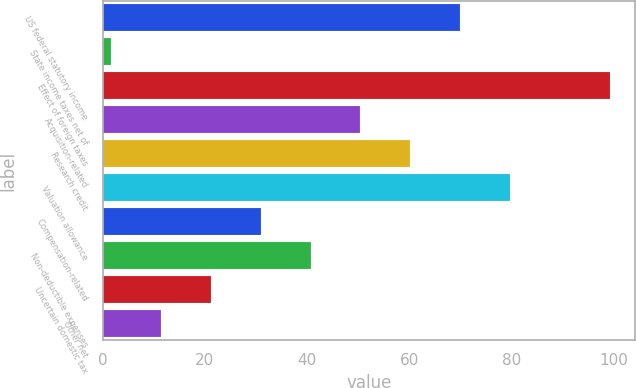Convert chart to OTSL. <chart><loc_0><loc_0><loc_500><loc_500><bar_chart><fcel>US federal statutory income<fcel>State income taxes net of<fcel>Effect of foreign taxes<fcel>Acquisition-related<fcel>Research credit<fcel>Valuation allowance<fcel>Compensation-related<fcel>Non-deductible expenses<fcel>Uncertain domestic tax<fcel>Other net<nl><fcel>69.88<fcel>1.7<fcel>99.1<fcel>50.4<fcel>60.14<fcel>79.62<fcel>30.92<fcel>40.66<fcel>21.18<fcel>11.44<nl></chart> 